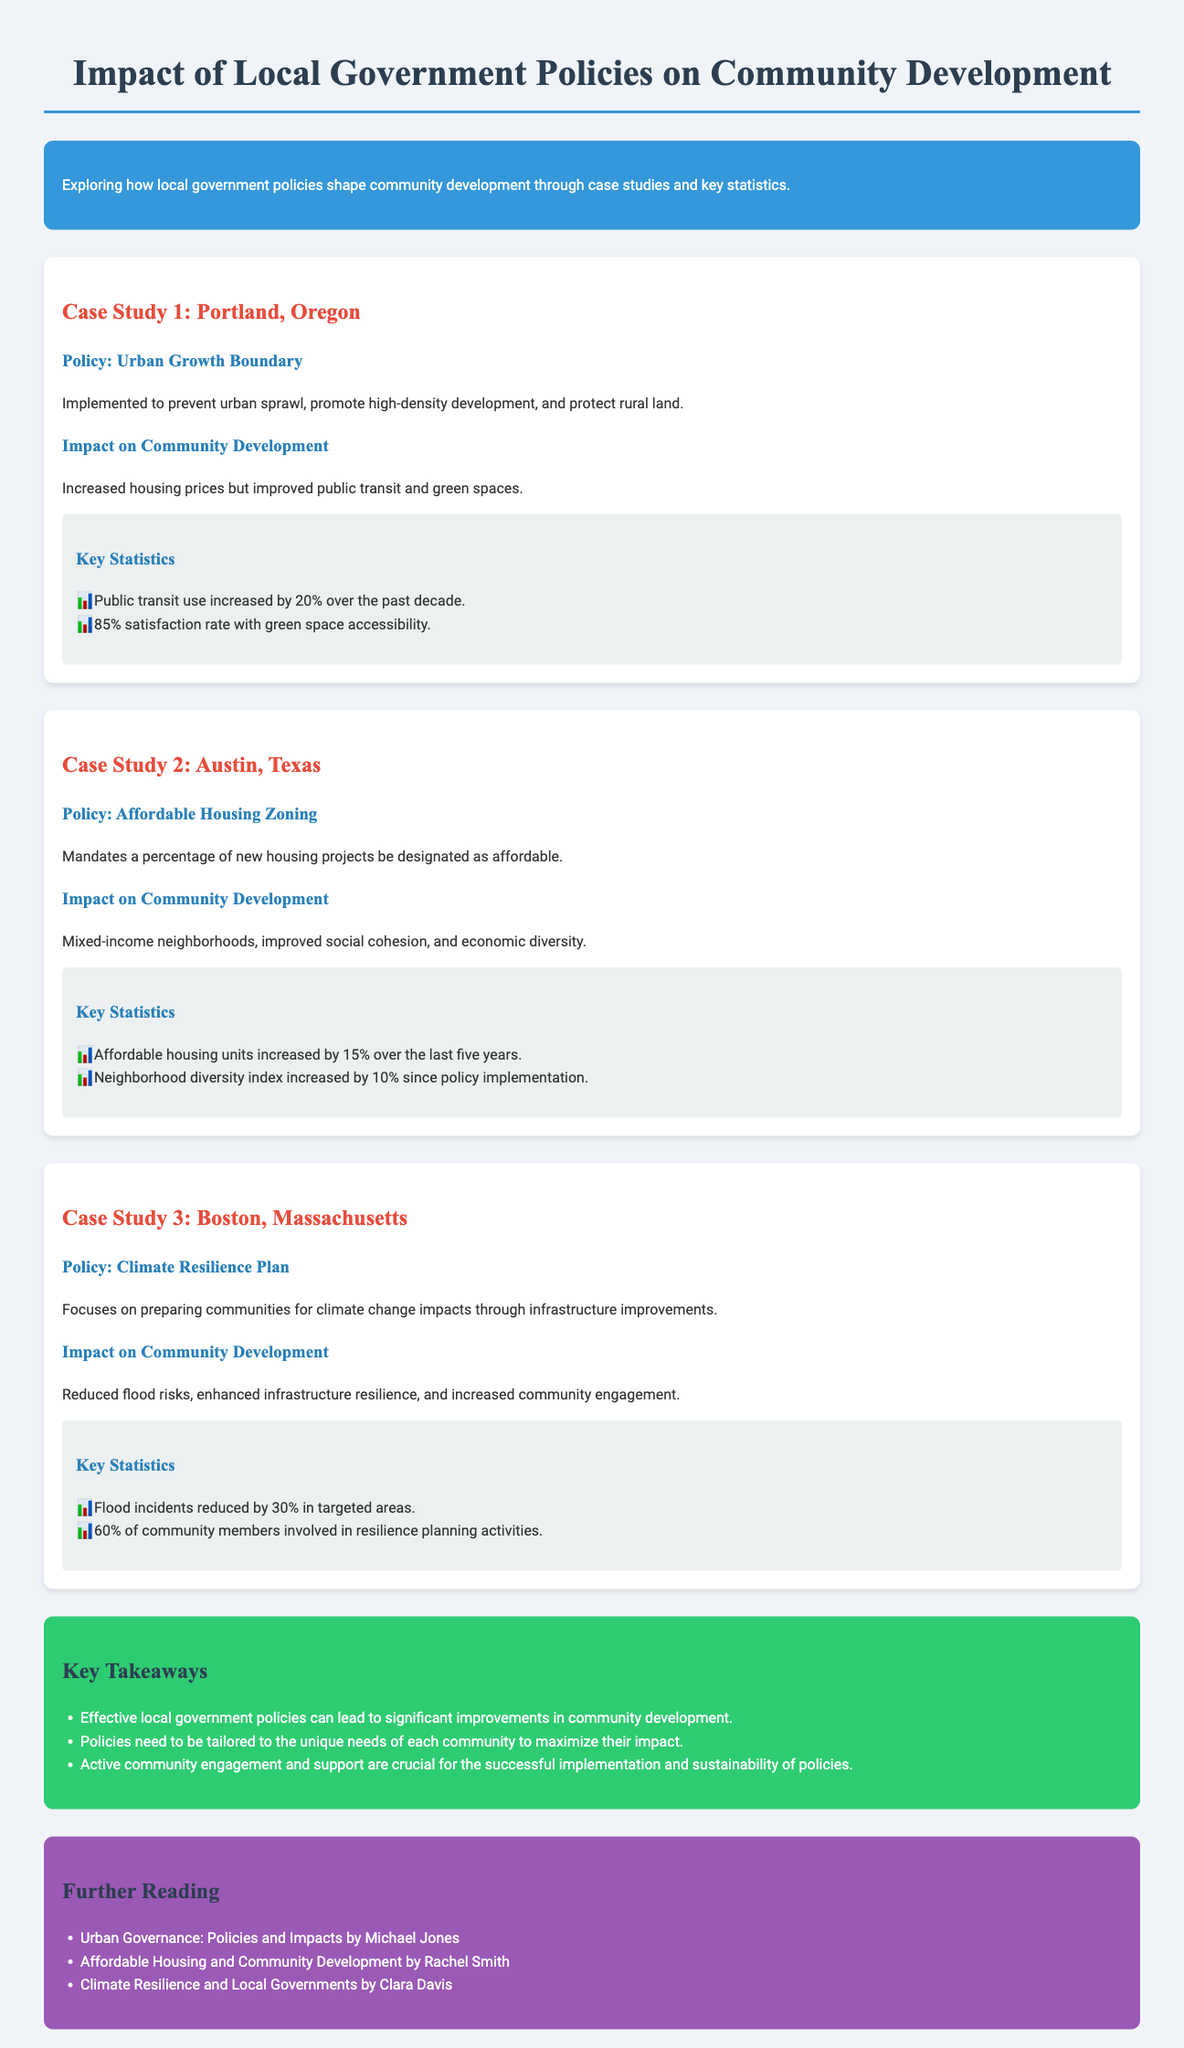What is the focus of the case study in Boston, Massachusetts? The case study in Boston focuses on the Climate Resilience Plan, which prepares communities for climate change impacts through infrastructure improvements.
Answer: Climate Resilience Plan What percentage of affordable housing units increased in Austin, Texas? The document states that affordable housing units increased by 15% over the last five years in Austin, Texas.
Answer: 15% What is the satisfaction rate with green space accessibility in Portland, Oregon? The satisfaction rate with green space accessibility in Portland is 85%.
Answer: 85% Which city implemented an Urban Growth Boundary policy? The municipality mentioned in the document that implemented an Urban Growth Boundary policy is Portland, Oregon.
Answer: Portland, Oregon What are the key takeaways mentioned in the infographic? The key takeaways emphasize the importance of effective local government policies, tailoring them to community needs, and the necessity of active community engagement.
Answer: Effective local government policies How much have flood incidents reduced in targeted areas of Boston? The document notes that flood incidents have reduced by 30% in targeted areas due to the climate resilience plan.
Answer: 30% What is the neighborhood diversity index increase in Austin since the policy implementation? The increase in the neighborhood diversity index in Austin since the policy implementation is 10%.
Answer: 10% What type of housing policy is mandated in Austin? The housing policy mandated in Austin requires a percentage of new housing projects to be designated as affordable.
Answer: Affordable Housing Zoning 